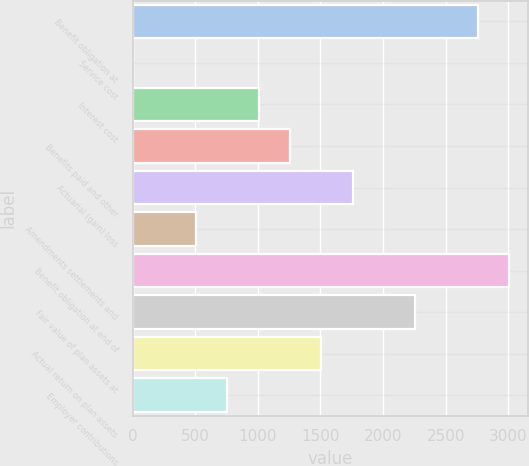Convert chart. <chart><loc_0><loc_0><loc_500><loc_500><bar_chart><fcel>Benefit obligation at<fcel>Service cost<fcel>Interest cost<fcel>Benefits paid and other<fcel>Actuarial (gain) loss<fcel>Amendments settlements and<fcel>Benefit obligation at end of<fcel>Fair value of plan assets at<fcel>Actual return on plan assets<fcel>Employer contributions<nl><fcel>2756.26<fcel>5.6<fcel>1005.84<fcel>1255.9<fcel>1756.02<fcel>505.72<fcel>3006.32<fcel>2256.14<fcel>1505.96<fcel>755.78<nl></chart> 